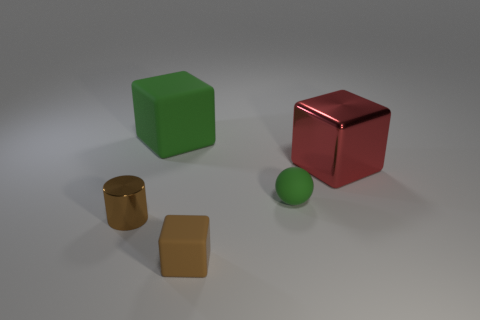Add 1 yellow metal cylinders. How many objects exist? 6 Subtract all spheres. How many objects are left? 4 Add 2 brown metal things. How many brown metal things are left? 3 Add 5 large metallic cubes. How many large metallic cubes exist? 6 Subtract 0 yellow balls. How many objects are left? 5 Subtract all tiny rubber cubes. Subtract all spheres. How many objects are left? 3 